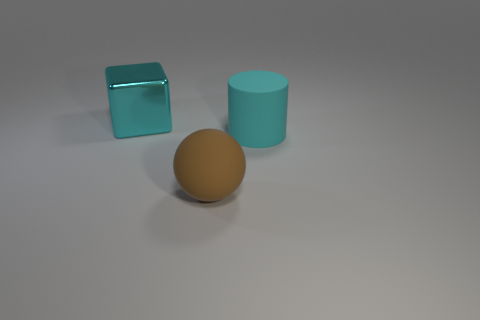Are there any other things that have the same shape as the metallic thing?
Your response must be concise. No. Is there a thing that has the same color as the shiny block?
Keep it short and to the point. Yes. Is the number of cylinders less than the number of green shiny cylinders?
Provide a short and direct response. No. How many objects are either gray metallic spheres or large cyan objects that are left of the matte sphere?
Keep it short and to the point. 1. Are there any big cyan objects that have the same material as the brown thing?
Give a very brief answer. Yes. There is a cyan cylinder that is the same size as the cyan metallic block; what material is it?
Your answer should be very brief. Rubber. What is the big object that is left of the matte object that is left of the cylinder made of?
Keep it short and to the point. Metal. Is the shape of the object behind the cyan rubber thing the same as  the cyan matte object?
Your answer should be compact. No. There is a thing that is the same material as the cyan cylinder; what color is it?
Offer a terse response. Brown. There is a big cyan object that is to the left of the large sphere; what material is it?
Offer a terse response. Metal. 